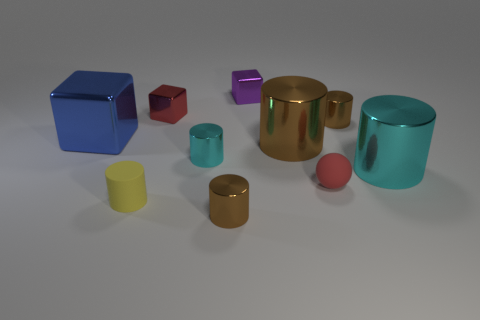Subtract all yellow cubes. How many brown cylinders are left? 3 Subtract all cyan cylinders. How many cylinders are left? 4 Subtract all big cylinders. How many cylinders are left? 4 Subtract all yellow cylinders. Subtract all blue spheres. How many cylinders are left? 5 Subtract all spheres. How many objects are left? 9 Add 6 matte cylinders. How many matte cylinders are left? 7 Add 7 tiny rubber objects. How many tiny rubber objects exist? 9 Subtract 0 gray cubes. How many objects are left? 10 Subtract all big green shiny spheres. Subtract all purple things. How many objects are left? 9 